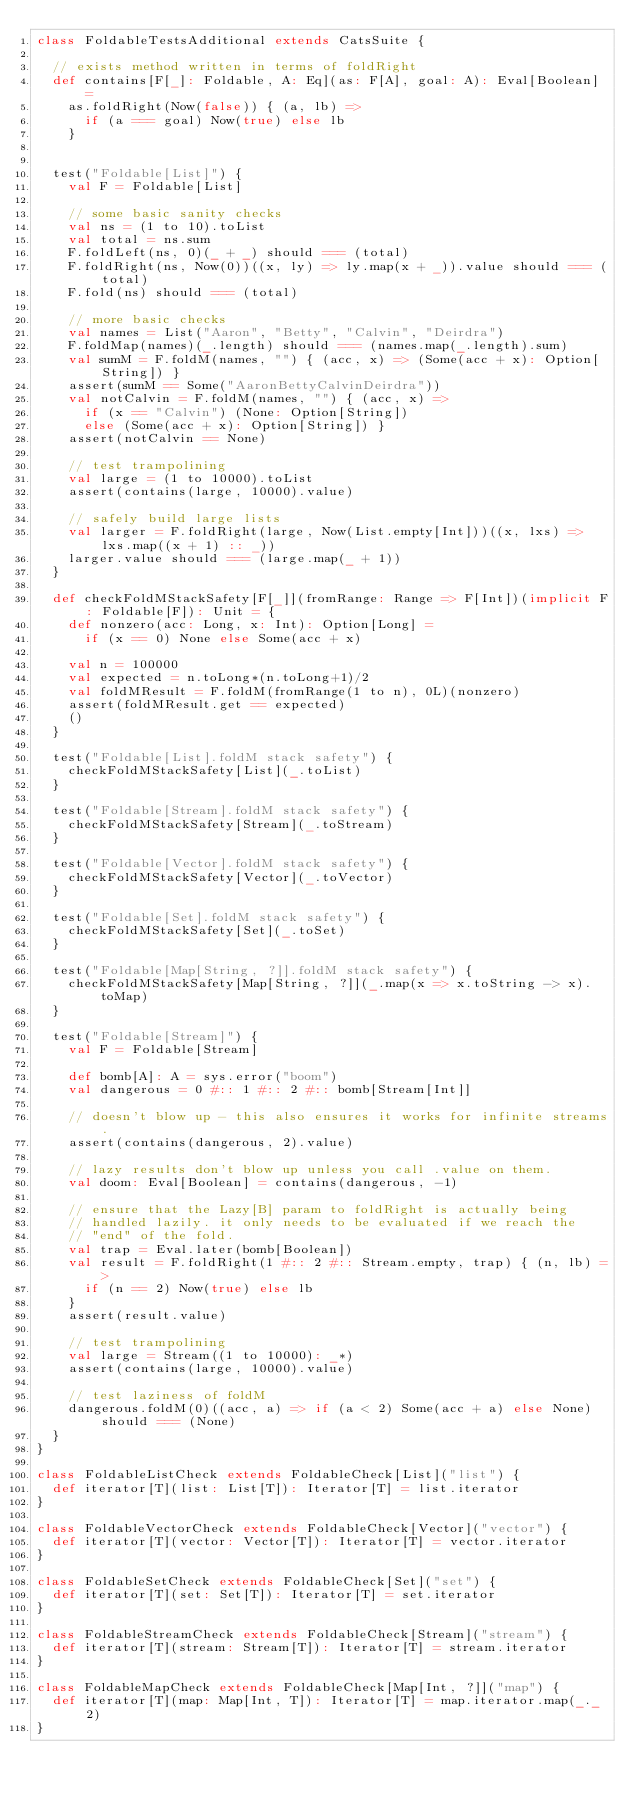<code> <loc_0><loc_0><loc_500><loc_500><_Scala_>class FoldableTestsAdditional extends CatsSuite {

  // exists method written in terms of foldRight
  def contains[F[_]: Foldable, A: Eq](as: F[A], goal: A): Eval[Boolean] =
    as.foldRight(Now(false)) { (a, lb) =>
      if (a === goal) Now(true) else lb
    }


  test("Foldable[List]") {
    val F = Foldable[List]

    // some basic sanity checks
    val ns = (1 to 10).toList
    val total = ns.sum
    F.foldLeft(ns, 0)(_ + _) should === (total)
    F.foldRight(ns, Now(0))((x, ly) => ly.map(x + _)).value should === (total)
    F.fold(ns) should === (total)

    // more basic checks
    val names = List("Aaron", "Betty", "Calvin", "Deirdra")
    F.foldMap(names)(_.length) should === (names.map(_.length).sum)
    val sumM = F.foldM(names, "") { (acc, x) => (Some(acc + x): Option[String]) }
    assert(sumM == Some("AaronBettyCalvinDeirdra"))
    val notCalvin = F.foldM(names, "") { (acc, x) =>
      if (x == "Calvin") (None: Option[String])
      else (Some(acc + x): Option[String]) }
    assert(notCalvin == None)

    // test trampolining
    val large = (1 to 10000).toList
    assert(contains(large, 10000).value)

    // safely build large lists
    val larger = F.foldRight(large, Now(List.empty[Int]))((x, lxs) => lxs.map((x + 1) :: _))
    larger.value should === (large.map(_ + 1))
  }

  def checkFoldMStackSafety[F[_]](fromRange: Range => F[Int])(implicit F: Foldable[F]): Unit = {
    def nonzero(acc: Long, x: Int): Option[Long] =
      if (x == 0) None else Some(acc + x)

    val n = 100000
    val expected = n.toLong*(n.toLong+1)/2
    val foldMResult = F.foldM(fromRange(1 to n), 0L)(nonzero)
    assert(foldMResult.get == expected)
    ()
  }

  test("Foldable[List].foldM stack safety") {
    checkFoldMStackSafety[List](_.toList)
  }

  test("Foldable[Stream].foldM stack safety") {
    checkFoldMStackSafety[Stream](_.toStream)
  }

  test("Foldable[Vector].foldM stack safety") {
    checkFoldMStackSafety[Vector](_.toVector)
  }

  test("Foldable[Set].foldM stack safety") {
    checkFoldMStackSafety[Set](_.toSet)
  }

  test("Foldable[Map[String, ?]].foldM stack safety") {
    checkFoldMStackSafety[Map[String, ?]](_.map(x => x.toString -> x).toMap)
  }

  test("Foldable[Stream]") {
    val F = Foldable[Stream]

    def bomb[A]: A = sys.error("boom")
    val dangerous = 0 #:: 1 #:: 2 #:: bomb[Stream[Int]]

    // doesn't blow up - this also ensures it works for infinite streams.
    assert(contains(dangerous, 2).value)

    // lazy results don't blow up unless you call .value on them.
    val doom: Eval[Boolean] = contains(dangerous, -1)

    // ensure that the Lazy[B] param to foldRight is actually being
    // handled lazily. it only needs to be evaluated if we reach the
    // "end" of the fold.
    val trap = Eval.later(bomb[Boolean])
    val result = F.foldRight(1 #:: 2 #:: Stream.empty, trap) { (n, lb) =>
      if (n == 2) Now(true) else lb
    }
    assert(result.value)

    // test trampolining
    val large = Stream((1 to 10000): _*)
    assert(contains(large, 10000).value)

    // test laziness of foldM
    dangerous.foldM(0)((acc, a) => if (a < 2) Some(acc + a) else None) should === (None)
  }
}

class FoldableListCheck extends FoldableCheck[List]("list") {
  def iterator[T](list: List[T]): Iterator[T] = list.iterator
}

class FoldableVectorCheck extends FoldableCheck[Vector]("vector") {
  def iterator[T](vector: Vector[T]): Iterator[T] = vector.iterator
}

class FoldableSetCheck extends FoldableCheck[Set]("set") {
  def iterator[T](set: Set[T]): Iterator[T] = set.iterator
}

class FoldableStreamCheck extends FoldableCheck[Stream]("stream") {
  def iterator[T](stream: Stream[T]): Iterator[T] = stream.iterator
}

class FoldableMapCheck extends FoldableCheck[Map[Int, ?]]("map") {
  def iterator[T](map: Map[Int, T]): Iterator[T] = map.iterator.map(_._2)
}
</code> 